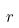<formula> <loc_0><loc_0><loc_500><loc_500>r</formula> 